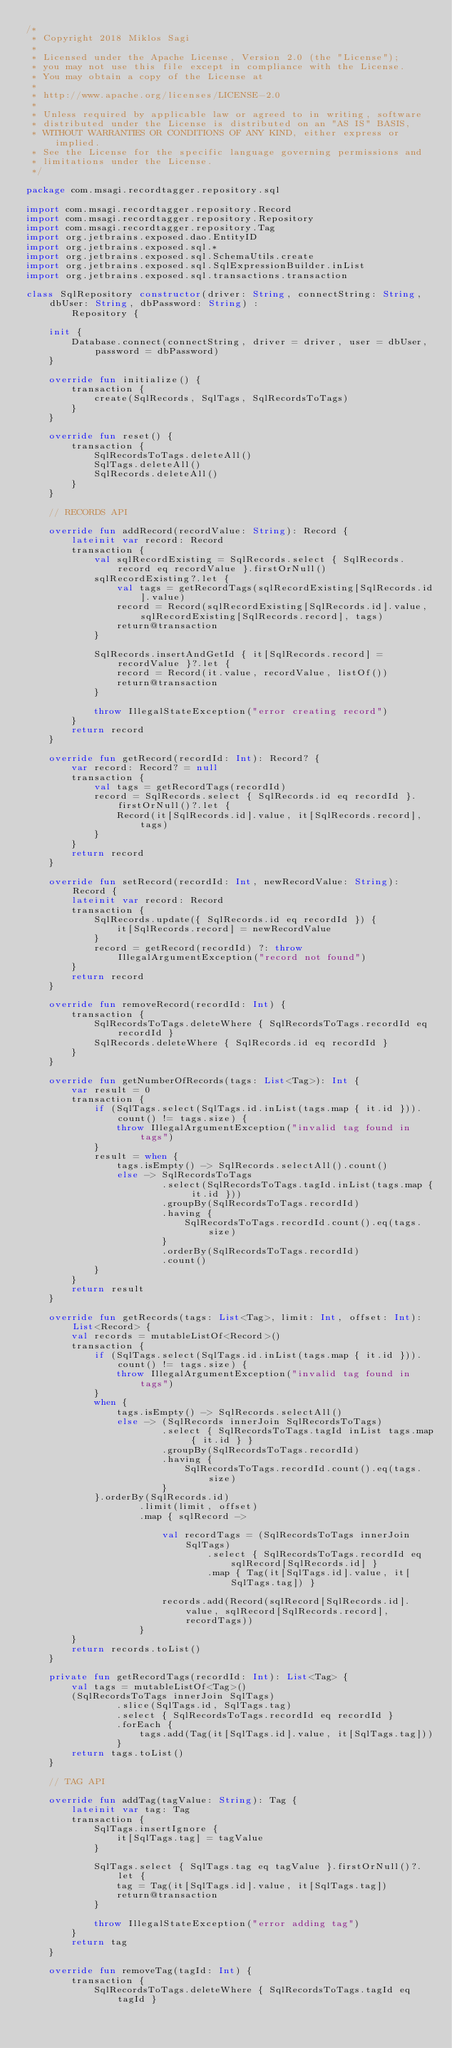Convert code to text. <code><loc_0><loc_0><loc_500><loc_500><_Kotlin_>/*
 * Copyright 2018 Miklos Sagi
 *
 * Licensed under the Apache License, Version 2.0 (the "License");
 * you may not use this file except in compliance with the License.
 * You may obtain a copy of the License at
 *
 * http://www.apache.org/licenses/LICENSE-2.0
 *
 * Unless required by applicable law or agreed to in writing, software
 * distributed under the License is distributed on an "AS IS" BASIS,
 * WITHOUT WARRANTIES OR CONDITIONS OF ANY KIND, either express or implied.
 * See the License for the specific language governing permissions and
 * limitations under the License.
 */

package com.msagi.recordtagger.repository.sql

import com.msagi.recordtagger.repository.Record
import com.msagi.recordtagger.repository.Repository
import com.msagi.recordtagger.repository.Tag
import org.jetbrains.exposed.dao.EntityID
import org.jetbrains.exposed.sql.*
import org.jetbrains.exposed.sql.SchemaUtils.create
import org.jetbrains.exposed.sql.SqlExpressionBuilder.inList
import org.jetbrains.exposed.sql.transactions.transaction

class SqlRepository constructor(driver: String, connectString: String, dbUser: String, dbPassword: String) :
        Repository {

    init {
        Database.connect(connectString, driver = driver, user = dbUser, password = dbPassword)
    }

    override fun initialize() {
        transaction {
            create(SqlRecords, SqlTags, SqlRecordsToTags)
        }
    }

    override fun reset() {
        transaction {
            SqlRecordsToTags.deleteAll()
            SqlTags.deleteAll()
            SqlRecords.deleteAll()
        }
    }

    // RECORDS API

    override fun addRecord(recordValue: String): Record {
        lateinit var record: Record
        transaction {
            val sqlRecordExisting = SqlRecords.select { SqlRecords.record eq recordValue }.firstOrNull()
            sqlRecordExisting?.let {
                val tags = getRecordTags(sqlRecordExisting[SqlRecords.id].value)
                record = Record(sqlRecordExisting[SqlRecords.id].value, sqlRecordExisting[SqlRecords.record], tags)
                return@transaction
            }

            SqlRecords.insertAndGetId { it[SqlRecords.record] = recordValue }?.let {
                record = Record(it.value, recordValue, listOf())
                return@transaction
            }

            throw IllegalStateException("error creating record")
        }
        return record
    }

    override fun getRecord(recordId: Int): Record? {
        var record: Record? = null
        transaction {
            val tags = getRecordTags(recordId)
            record = SqlRecords.select { SqlRecords.id eq recordId }.firstOrNull()?.let {
                Record(it[SqlRecords.id].value, it[SqlRecords.record], tags)
            }
        }
        return record
    }

    override fun setRecord(recordId: Int, newRecordValue: String): Record {
        lateinit var record: Record
        transaction {
            SqlRecords.update({ SqlRecords.id eq recordId }) {
                it[SqlRecords.record] = newRecordValue
            }
            record = getRecord(recordId) ?: throw IllegalArgumentException("record not found")
        }
        return record
    }

    override fun removeRecord(recordId: Int) {
        transaction {
            SqlRecordsToTags.deleteWhere { SqlRecordsToTags.recordId eq recordId }
            SqlRecords.deleteWhere { SqlRecords.id eq recordId }
        }
    }

    override fun getNumberOfRecords(tags: List<Tag>): Int {
        var result = 0
        transaction {
            if (SqlTags.select(SqlTags.id.inList(tags.map { it.id })).count() != tags.size) {
                throw IllegalArgumentException("invalid tag found in tags")
            }
            result = when {
                tags.isEmpty() -> SqlRecords.selectAll().count()
                else -> SqlRecordsToTags
                        .select(SqlRecordsToTags.tagId.inList(tags.map { it.id }))
                        .groupBy(SqlRecordsToTags.recordId)
                        .having {
                            SqlRecordsToTags.recordId.count().eq(tags.size)
                        }
                        .orderBy(SqlRecordsToTags.recordId)
                        .count()
            }
        }
        return result
    }

    override fun getRecords(tags: List<Tag>, limit: Int, offset: Int): List<Record> {
        val records = mutableListOf<Record>()
        transaction {
            if (SqlTags.select(SqlTags.id.inList(tags.map { it.id })).count() != tags.size) {
                throw IllegalArgumentException("invalid tag found in tags")
            }
            when {
                tags.isEmpty() -> SqlRecords.selectAll()
                else -> (SqlRecords innerJoin SqlRecordsToTags)
                        .select { SqlRecordsToTags.tagId inList tags.map { it.id } }
                        .groupBy(SqlRecordsToTags.recordId)
                        .having {
                            SqlRecordsToTags.recordId.count().eq(tags.size)
                        }
            }.orderBy(SqlRecords.id)
                    .limit(limit, offset)
                    .map { sqlRecord ->

                        val recordTags = (SqlRecordsToTags innerJoin SqlTags)
                                .select { SqlRecordsToTags.recordId eq sqlRecord[SqlRecords.id] }
                                .map { Tag(it[SqlTags.id].value, it[SqlTags.tag]) }

                        records.add(Record(sqlRecord[SqlRecords.id].value, sqlRecord[SqlRecords.record], recordTags))
                    }
        }
        return records.toList()
    }

    private fun getRecordTags(recordId: Int): List<Tag> {
        val tags = mutableListOf<Tag>()
        (SqlRecordsToTags innerJoin SqlTags)
                .slice(SqlTags.id, SqlTags.tag)
                .select { SqlRecordsToTags.recordId eq recordId }
                .forEach {
                    tags.add(Tag(it[SqlTags.id].value, it[SqlTags.tag]))
                }
        return tags.toList()
    }

    // TAG API

    override fun addTag(tagValue: String): Tag {
        lateinit var tag: Tag
        transaction {
            SqlTags.insertIgnore {
                it[SqlTags.tag] = tagValue
            }

            SqlTags.select { SqlTags.tag eq tagValue }.firstOrNull()?.let {
                tag = Tag(it[SqlTags.id].value, it[SqlTags.tag])
                return@transaction
            }

            throw IllegalStateException("error adding tag")
        }
        return tag
    }

    override fun removeTag(tagId: Int) {
        transaction {
            SqlRecordsToTags.deleteWhere { SqlRecordsToTags.tagId eq tagId }</code> 